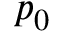<formula> <loc_0><loc_0><loc_500><loc_500>p _ { 0 }</formula> 